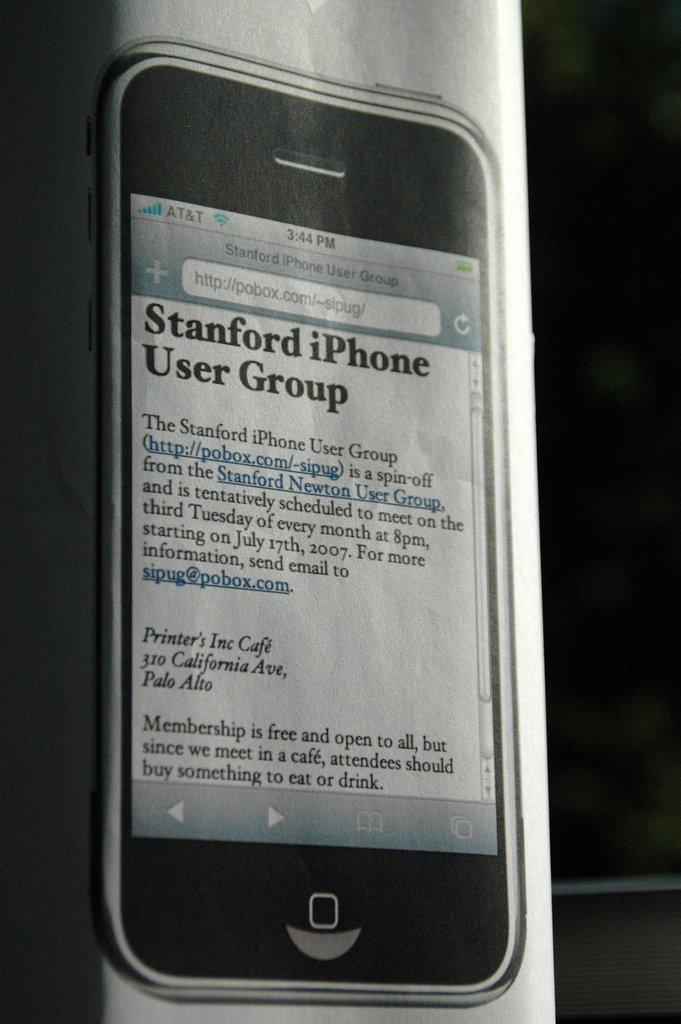<image>
Relay a brief, clear account of the picture shown. A picture of a cell phone with a page pulled up that says Stanford iPhone User Group on it. 